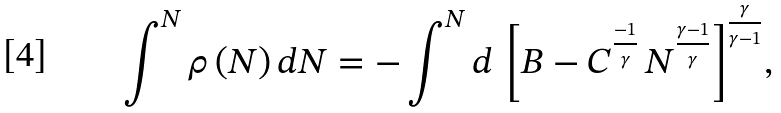<formula> <loc_0><loc_0><loc_500><loc_500>\int ^ { N } { \rho \, ( N ) \, d N } = - \int ^ { N } { d \, \left [ B - C ^ { \frac { - 1 } { \gamma } } \, N ^ { \frac { \gamma - 1 } { \gamma } } \right ] ^ { \frac { \gamma } { \gamma - 1 } } } ,</formula> 